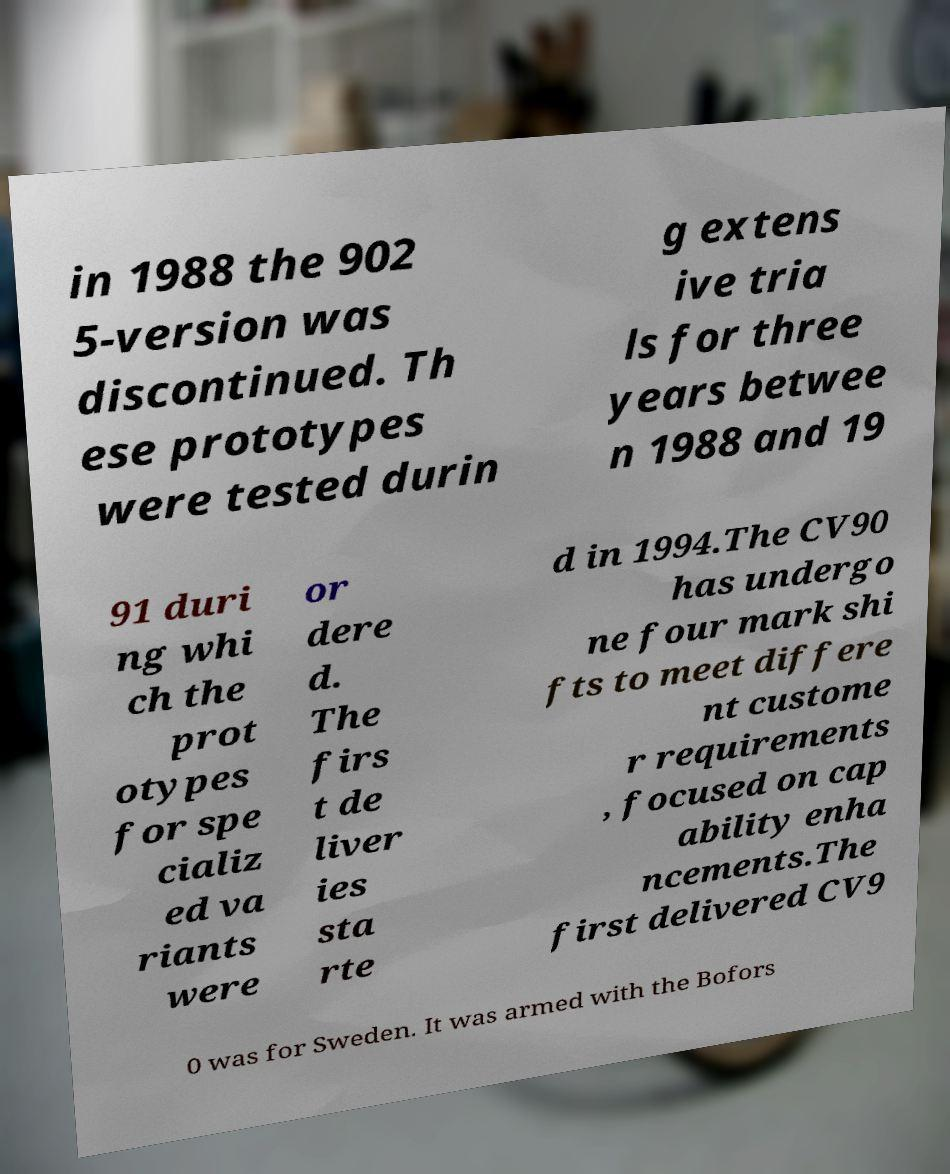Can you read and provide the text displayed in the image?This photo seems to have some interesting text. Can you extract and type it out for me? in 1988 the 902 5-version was discontinued. Th ese prototypes were tested durin g extens ive tria ls for three years betwee n 1988 and 19 91 duri ng whi ch the prot otypes for spe cializ ed va riants were or dere d. The firs t de liver ies sta rte d in 1994.The CV90 has undergo ne four mark shi fts to meet differe nt custome r requirements , focused on cap ability enha ncements.The first delivered CV9 0 was for Sweden. It was armed with the Bofors 